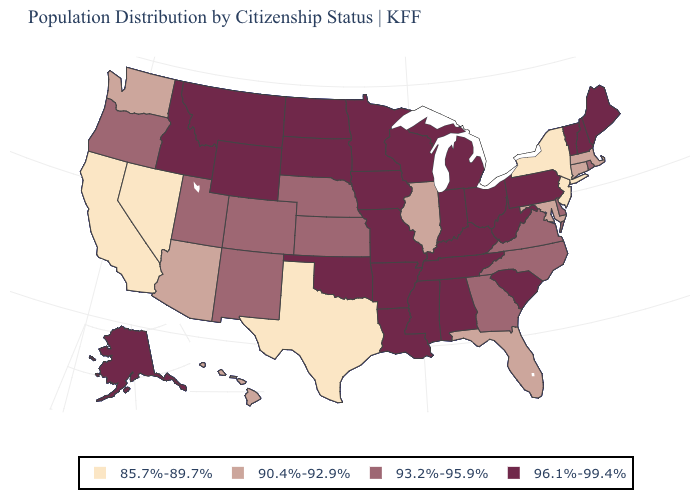Is the legend a continuous bar?
Short answer required. No. Which states have the lowest value in the West?
Short answer required. California, Nevada. What is the lowest value in the West?
Be succinct. 85.7%-89.7%. Is the legend a continuous bar?
Be succinct. No. What is the lowest value in the Northeast?
Quick response, please. 85.7%-89.7%. Among the states that border Louisiana , which have the highest value?
Concise answer only. Arkansas, Mississippi. Does the map have missing data?
Write a very short answer. No. Which states hav the highest value in the South?
Write a very short answer. Alabama, Arkansas, Kentucky, Louisiana, Mississippi, Oklahoma, South Carolina, Tennessee, West Virginia. Does New York have the lowest value in the Northeast?
Give a very brief answer. Yes. Name the states that have a value in the range 93.2%-95.9%?
Keep it brief. Colorado, Delaware, Georgia, Kansas, Nebraska, New Mexico, North Carolina, Oregon, Rhode Island, Utah, Virginia. Name the states that have a value in the range 85.7%-89.7%?
Short answer required. California, Nevada, New Jersey, New York, Texas. Name the states that have a value in the range 90.4%-92.9%?
Quick response, please. Arizona, Connecticut, Florida, Hawaii, Illinois, Maryland, Massachusetts, Washington. What is the value of Florida?
Concise answer only. 90.4%-92.9%. What is the value of Nebraska?
Concise answer only. 93.2%-95.9%. Among the states that border Florida , does Georgia have the highest value?
Answer briefly. No. 